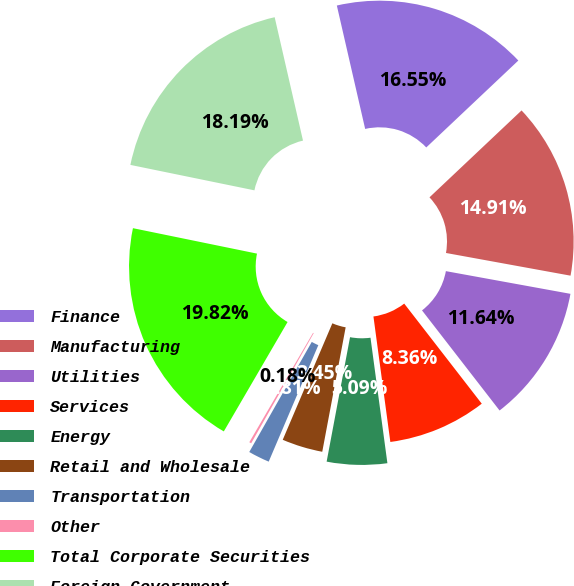Convert chart. <chart><loc_0><loc_0><loc_500><loc_500><pie_chart><fcel>Finance<fcel>Manufacturing<fcel>Utilities<fcel>Services<fcel>Energy<fcel>Retail and Wholesale<fcel>Transportation<fcel>Other<fcel>Total Corporate Securities<fcel>Foreign Government<nl><fcel>16.55%<fcel>14.91%<fcel>11.64%<fcel>8.36%<fcel>5.09%<fcel>3.45%<fcel>1.81%<fcel>0.18%<fcel>19.82%<fcel>18.19%<nl></chart> 